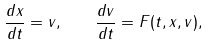Convert formula to latex. <formula><loc_0><loc_0><loc_500><loc_500>\frac { d x } { d t } = v , \quad \frac { d v } { d t } = F ( t , x , v ) ,</formula> 